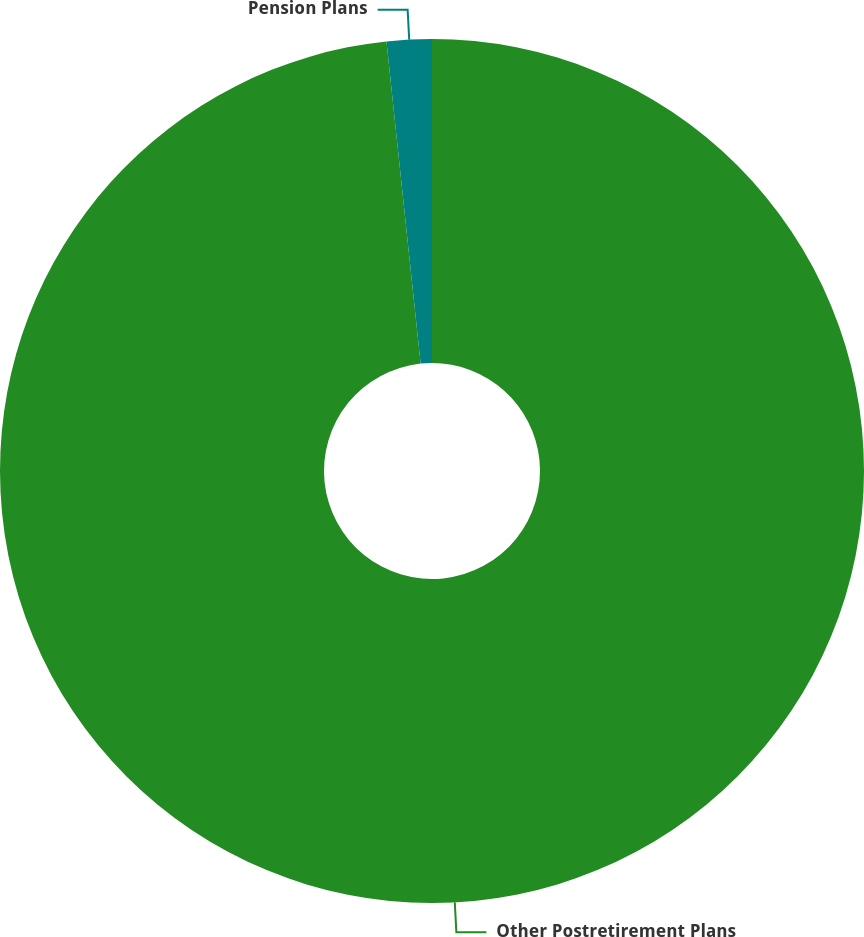Convert chart. <chart><loc_0><loc_0><loc_500><loc_500><pie_chart><fcel>Other Postretirement Plans<fcel>Pension Plans<nl><fcel>98.32%<fcel>1.68%<nl></chart> 